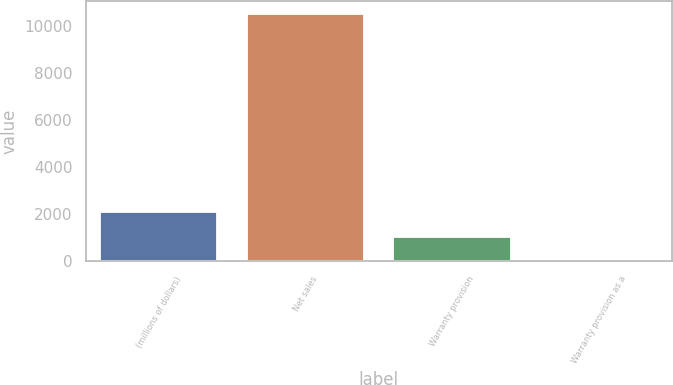<chart> <loc_0><loc_0><loc_500><loc_500><bar_chart><fcel>(millions of dollars)<fcel>Net sales<fcel>Warranty provision<fcel>Warranty provision as a<nl><fcel>2106.48<fcel>10529.6<fcel>1053.59<fcel>0.7<nl></chart> 